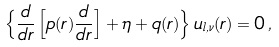<formula> <loc_0><loc_0><loc_500><loc_500>\left \{ \frac { d } { d r } \left [ p ( r ) \frac { d } { d r } \right ] + \eta + q ( r ) \right \} u _ { l , \nu } ( r ) = 0 \, ,</formula> 